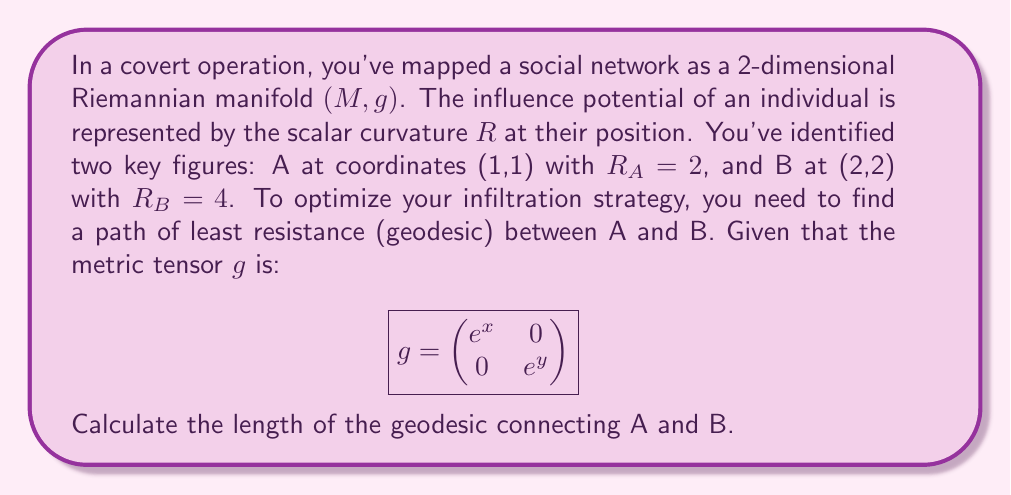Can you answer this question? To solve this problem, we'll follow these steps:

1) First, recall that the geodesic equation for a curve $\gamma(t) = (x(t), y(t))$ on a Riemannian manifold is:

   $$\frac{d^2x^i}{dt^2} + \Gamma^i_{jk}\frac{dx^j}{dt}\frac{dx^k}{dt} = 0$$

   where $\Gamma^i_{jk}$ are the Christoffel symbols.

2) For our metric, the non-zero Christoffel symbols are:
   
   $$\Gamma^1_{11} = \frac{1}{2}, \quad \Gamma^2_{22} = \frac{1}{2}$$

3) This gives us the system of differential equations:

   $$\frac{d^2x}{dt^2} + \frac{1}{2}\left(\frac{dx}{dt}\right)^2 = 0$$
   $$\frac{d^2y}{dt^2} + \frac{1}{2}\left(\frac{dy}{dt}\right)^2 = 0$$

4) The solutions to these equations are:

   $$x(t) = 2\log(at + b)$$
   $$y(t) = 2\log(ct + d)$$

   where $a, b, c, d$ are constants determined by boundary conditions.

5) Given the boundary conditions $x(0) = 1, y(0) = 1, x(1) = 2, y(1) = 2$, we can determine:

   $$x(t) = 2\log(e^{1/2}t + e^{1/2})$$
   $$y(t) = 2\log(e^{1/2}t + e^{1/2})$$

6) The length of the geodesic is given by:

   $$L = \int_0^1 \sqrt{g_{11}\left(\frac{dx}{dt}\right)^2 + g_{22}\left(\frac{dy}{dt}\right)^2} dt$$

7) Substituting our metric and geodesic equations:

   $$L = \int_0^1 \sqrt{e^x\left(\frac{1}{e^{1/2}t + e^{1/2}}\right)^2 + e^y\left(\frac{1}{e^{1/2}t + e^{1/2}}\right)^2} dt$$

8) Simplifying:

   $$L = \int_0^1 \sqrt{2}\left(\frac{1}{e^{1/2}t + e^{1/2}}\right) dt = \sqrt{2}[2 - 2e^{-1/2}]$$
Answer: The length of the geodesic connecting A and B is $\sqrt{2}[2 - 2e^{-1/2}] \approx 1.2203$. 